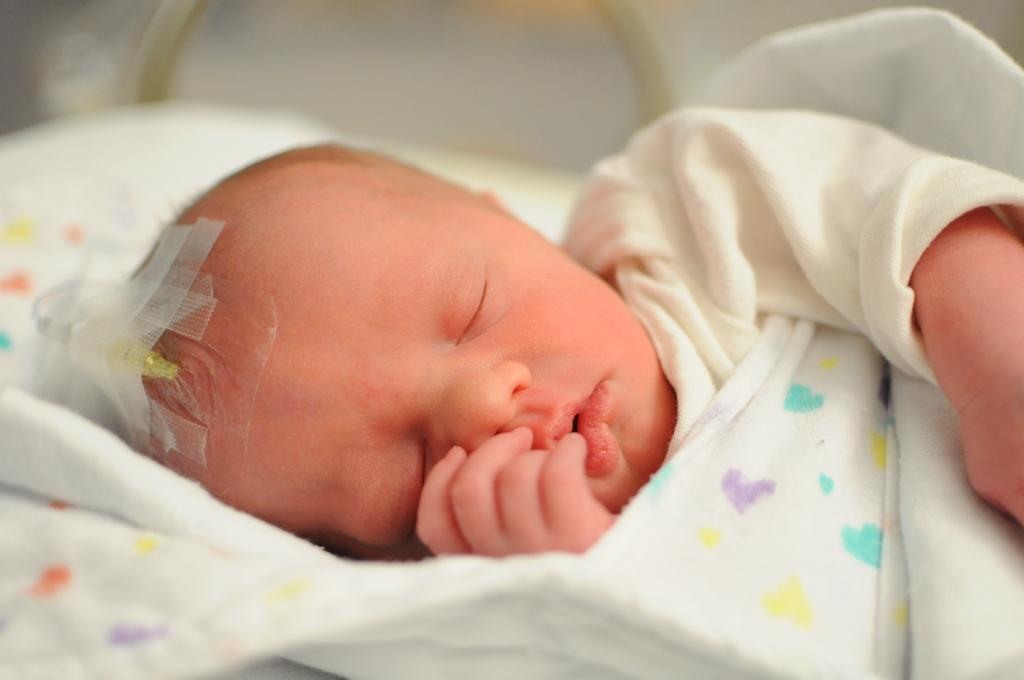What is the main subject of the image? There is a baby lying in the image. What can be seen on the left side of the image? There are plasters and a needle on the left side of the image. What type of crate is being used to transport the baby in the image? There is no crate present in the image; the baby is lying on a surface. 